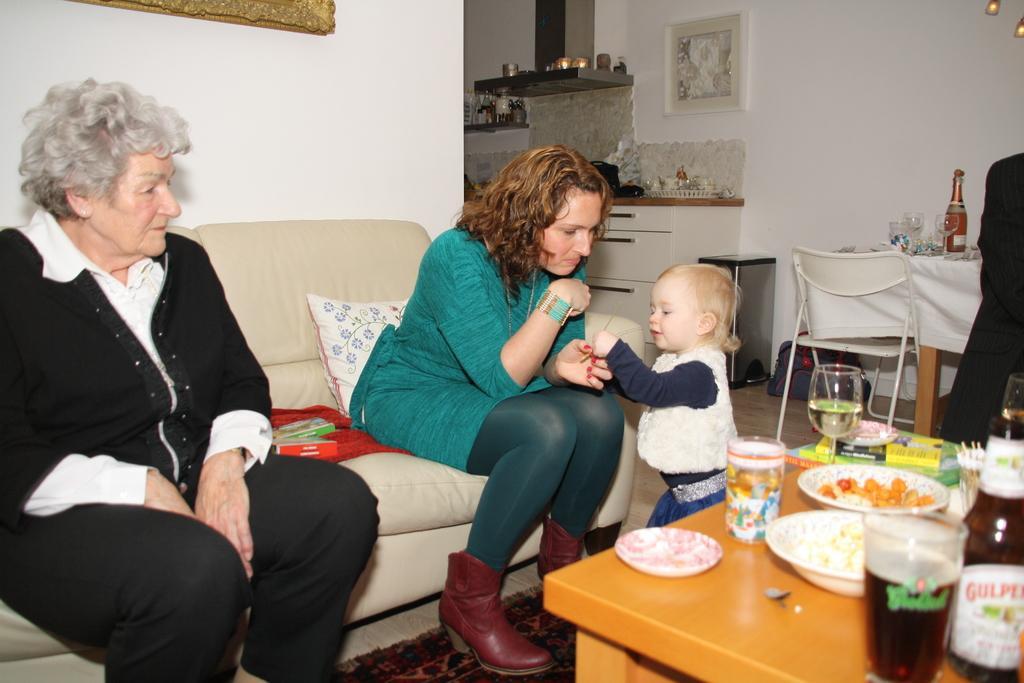Could you give a brief overview of what you see in this image? The photo is taken inside a room. In the left side there is a sofa. On the sofa two ladies are sitting. In front of them there is a table. On the table there are glasses,bowl with food and some other stuff. In the right side in the middle there is another table and chair. On the table there are glasses and bottle. In the middle there is a kid standing. In the back there is drawer candle and some other thing. There is a carpet on the floor. The lady on the left is wearing black dress. The wall is white. 